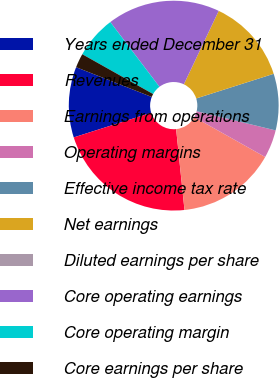Convert chart to OTSL. <chart><loc_0><loc_0><loc_500><loc_500><pie_chart><fcel>Years ended December 31<fcel>Revenues<fcel>Earnings from operations<fcel>Operating margins<fcel>Effective income tax rate<fcel>Net earnings<fcel>Diluted earnings per share<fcel>Core operating earnings<fcel>Core operating margin<fcel>Core earnings per share<nl><fcel>10.87%<fcel>21.74%<fcel>15.22%<fcel>4.35%<fcel>8.7%<fcel>13.04%<fcel>0.0%<fcel>17.39%<fcel>6.52%<fcel>2.18%<nl></chart> 